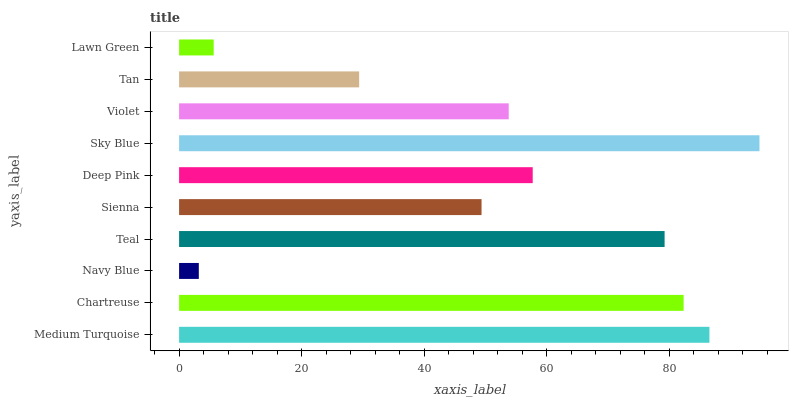Is Navy Blue the minimum?
Answer yes or no. Yes. Is Sky Blue the maximum?
Answer yes or no. Yes. Is Chartreuse the minimum?
Answer yes or no. No. Is Chartreuse the maximum?
Answer yes or no. No. Is Medium Turquoise greater than Chartreuse?
Answer yes or no. Yes. Is Chartreuse less than Medium Turquoise?
Answer yes or no. Yes. Is Chartreuse greater than Medium Turquoise?
Answer yes or no. No. Is Medium Turquoise less than Chartreuse?
Answer yes or no. No. Is Deep Pink the high median?
Answer yes or no. Yes. Is Violet the low median?
Answer yes or no. Yes. Is Sienna the high median?
Answer yes or no. No. Is Navy Blue the low median?
Answer yes or no. No. 